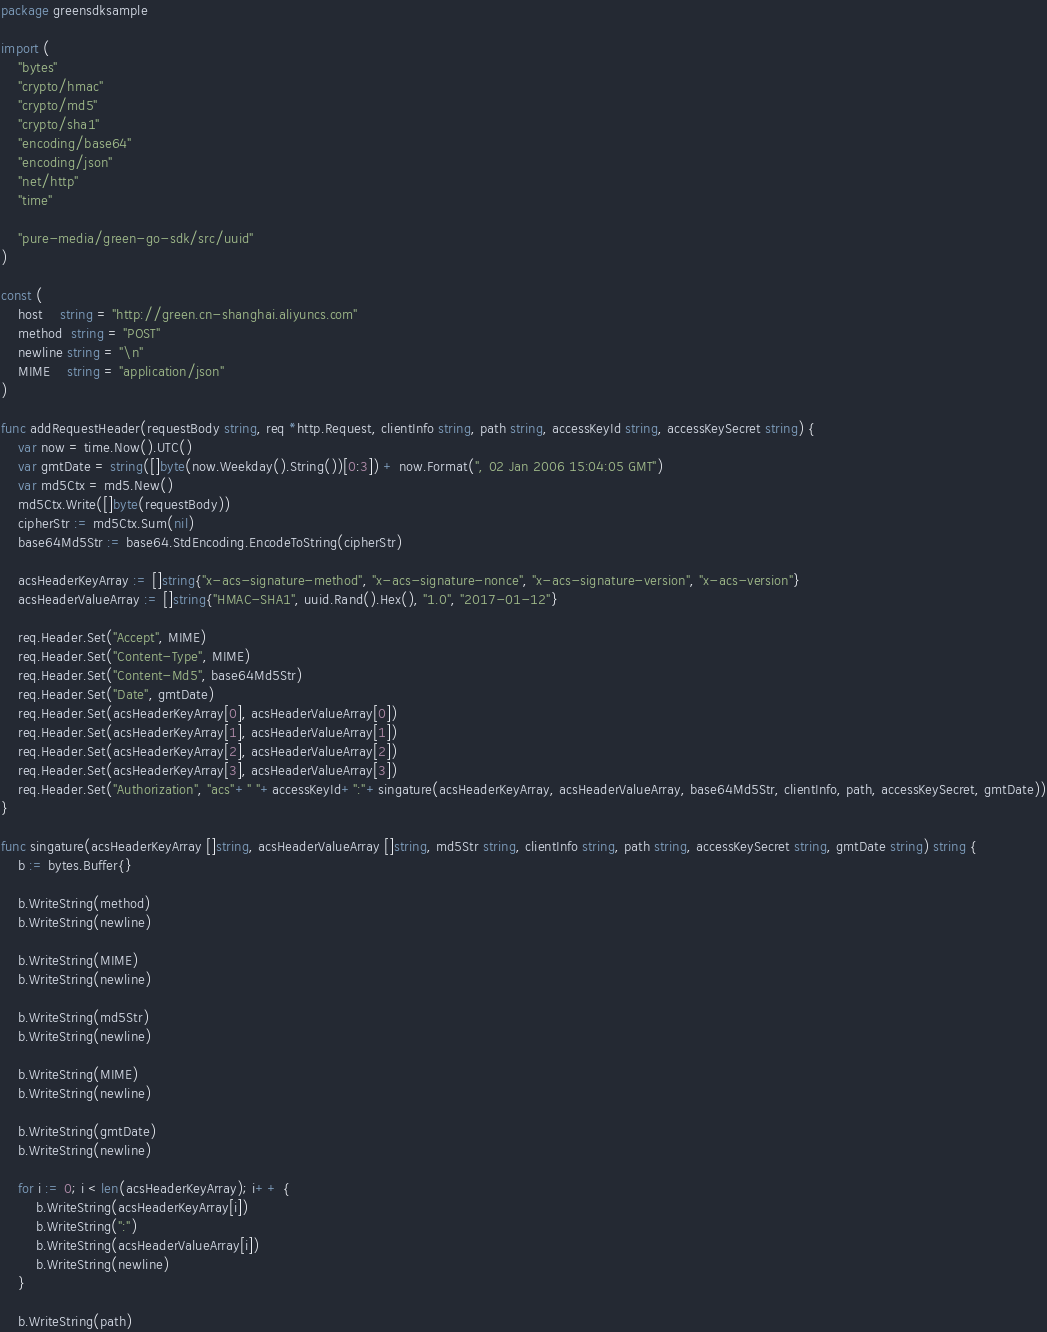<code> <loc_0><loc_0><loc_500><loc_500><_Go_>package greensdksample

import (
	"bytes"
	"crypto/hmac"
	"crypto/md5"
	"crypto/sha1"
	"encoding/base64"
	"encoding/json"
	"net/http"
	"time"

	"pure-media/green-go-sdk/src/uuid"
)

const (
	host    string = "http://green.cn-shanghai.aliyuncs.com"
	method  string = "POST"
	newline string = "\n"
	MIME    string = "application/json"
)

func addRequestHeader(requestBody string, req *http.Request, clientInfo string, path string, accessKeyId string, accessKeySecret string) {
	var now = time.Now().UTC()
	var gmtDate = string([]byte(now.Weekday().String())[0:3]) + now.Format(", 02 Jan 2006 15:04:05 GMT")
	var md5Ctx = md5.New()
	md5Ctx.Write([]byte(requestBody))
	cipherStr := md5Ctx.Sum(nil)
	base64Md5Str := base64.StdEncoding.EncodeToString(cipherStr)

	acsHeaderKeyArray := []string{"x-acs-signature-method", "x-acs-signature-nonce", "x-acs-signature-version", "x-acs-version"}
	acsHeaderValueArray := []string{"HMAC-SHA1", uuid.Rand().Hex(), "1.0", "2017-01-12"}

	req.Header.Set("Accept", MIME)
	req.Header.Set("Content-Type", MIME)
	req.Header.Set("Content-Md5", base64Md5Str)
	req.Header.Set("Date", gmtDate)
	req.Header.Set(acsHeaderKeyArray[0], acsHeaderValueArray[0])
	req.Header.Set(acsHeaderKeyArray[1], acsHeaderValueArray[1])
	req.Header.Set(acsHeaderKeyArray[2], acsHeaderValueArray[2])
	req.Header.Set(acsHeaderKeyArray[3], acsHeaderValueArray[3])
	req.Header.Set("Authorization", "acs"+" "+accessKeyId+":"+singature(acsHeaderKeyArray, acsHeaderValueArray, base64Md5Str, clientInfo, path, accessKeySecret, gmtDate))
}

func singature(acsHeaderKeyArray []string, acsHeaderValueArray []string, md5Str string, clientInfo string, path string, accessKeySecret string, gmtDate string) string {
	b := bytes.Buffer{}

	b.WriteString(method)
	b.WriteString(newline)

	b.WriteString(MIME)
	b.WriteString(newline)

	b.WriteString(md5Str)
	b.WriteString(newline)

	b.WriteString(MIME)
	b.WriteString(newline)

	b.WriteString(gmtDate)
	b.WriteString(newline)

	for i := 0; i < len(acsHeaderKeyArray); i++ {
		b.WriteString(acsHeaderKeyArray[i])
		b.WriteString(":")
		b.WriteString(acsHeaderValueArray[i])
		b.WriteString(newline)
	}

	b.WriteString(path)</code> 